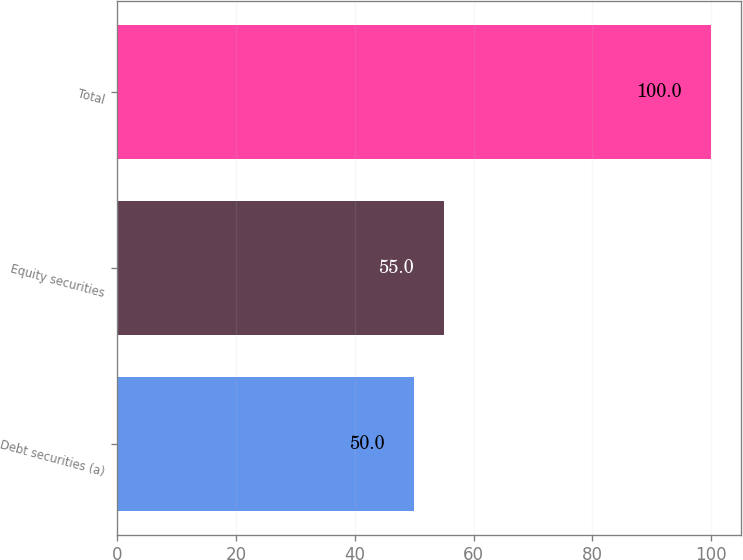<chart> <loc_0><loc_0><loc_500><loc_500><bar_chart><fcel>Debt securities (a)<fcel>Equity securities<fcel>Total<nl><fcel>50<fcel>55<fcel>100<nl></chart> 